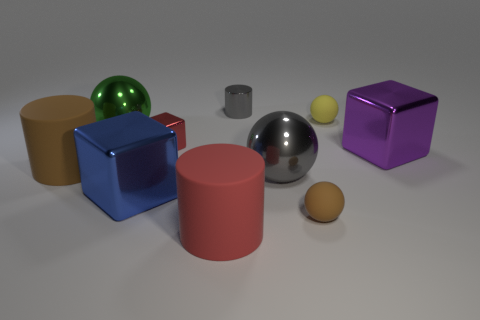Subtract all blue metallic cubes. How many cubes are left? 2 Subtract all red cylinders. How many cylinders are left? 2 Subtract 2 spheres. How many spheres are left? 2 Subtract all green cubes. How many red spheres are left? 0 Add 9 small red metal objects. How many small red metal objects exist? 10 Subtract 1 gray cylinders. How many objects are left? 9 Subtract all cubes. How many objects are left? 7 Subtract all cyan spheres. Subtract all blue cylinders. How many spheres are left? 4 Subtract all green metallic objects. Subtract all large red rubber cylinders. How many objects are left? 8 Add 4 brown matte spheres. How many brown matte spheres are left? 5 